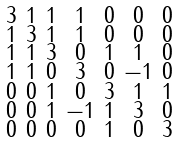<formula> <loc_0><loc_0><loc_500><loc_500>\begin{smallmatrix} 3 & 1 & 1 & 1 & 0 & 0 & 0 \\ 1 & 3 & 1 & 1 & 0 & 0 & 0 \\ 1 & 1 & 3 & 0 & 1 & 1 & 0 \\ 1 & 1 & 0 & 3 & 0 & - 1 & 0 \\ 0 & 0 & 1 & 0 & 3 & 1 & 1 \\ 0 & 0 & 1 & - 1 & 1 & 3 & 0 \\ 0 & 0 & 0 & 0 & 1 & 0 & 3 \end{smallmatrix}</formula> 